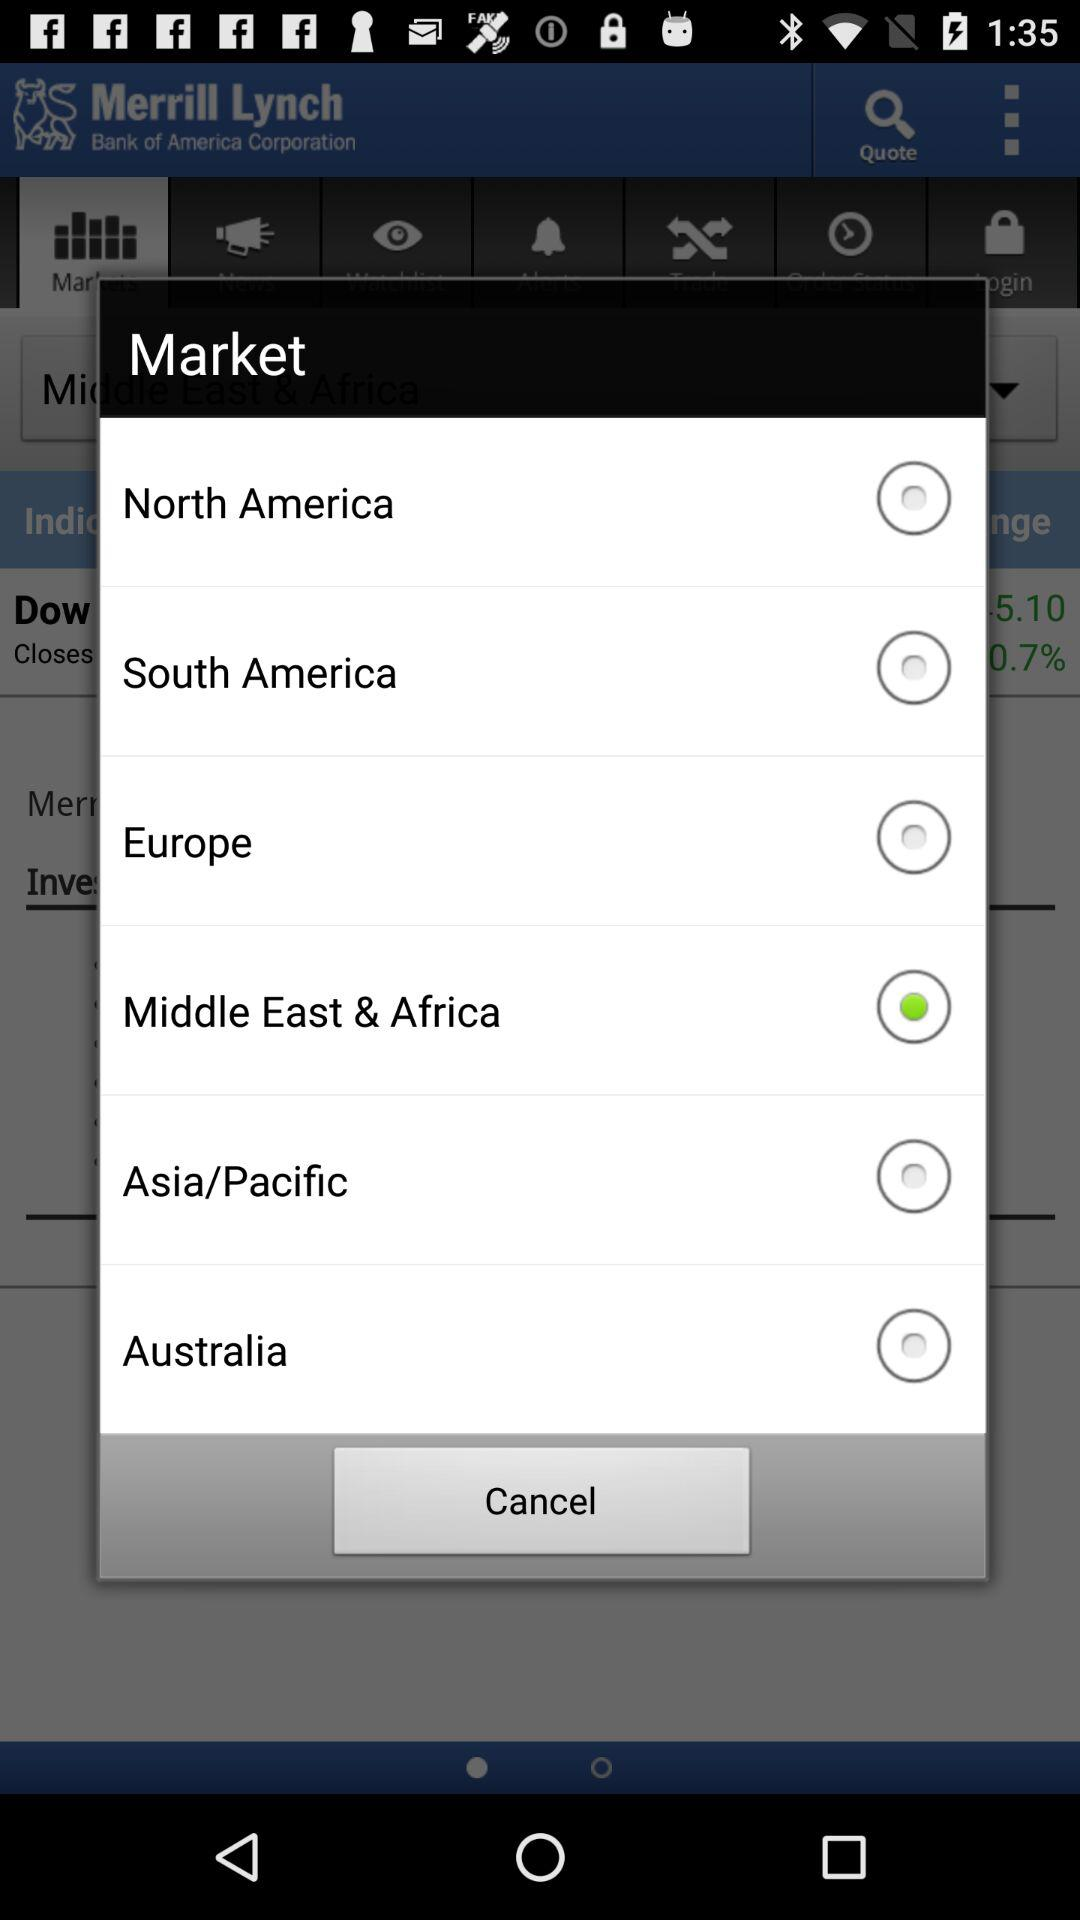How many regions are available to select?
Answer the question using a single word or phrase. 6 